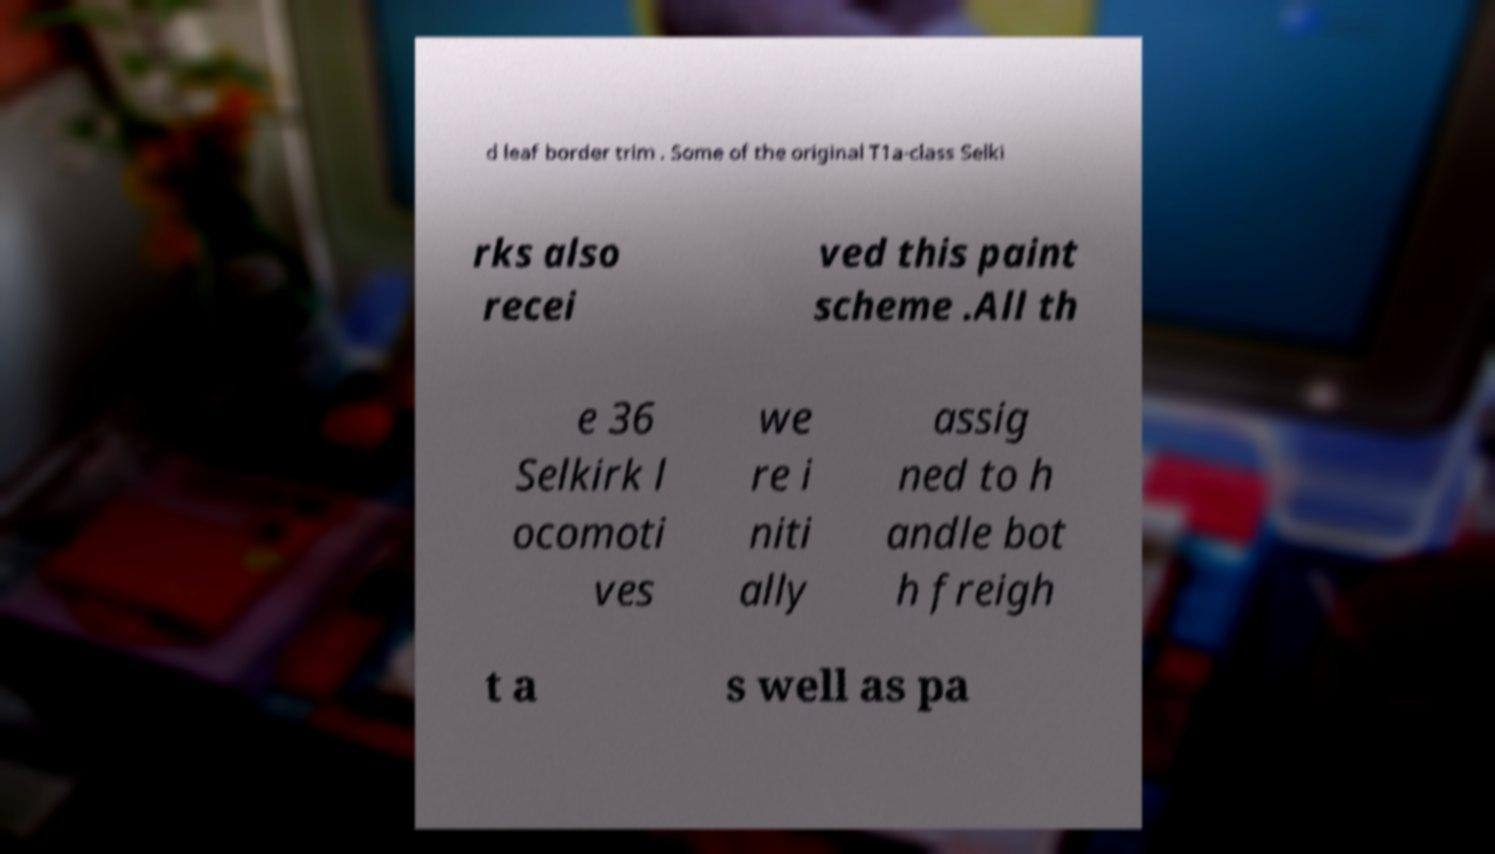Can you accurately transcribe the text from the provided image for me? d leaf border trim . Some of the original T1a-class Selki rks also recei ved this paint scheme .All th e 36 Selkirk l ocomoti ves we re i niti ally assig ned to h andle bot h freigh t a s well as pa 